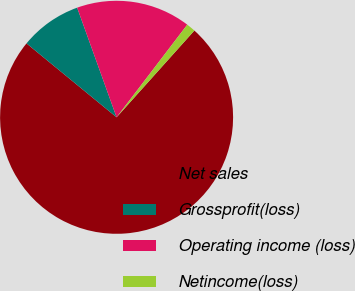<chart> <loc_0><loc_0><loc_500><loc_500><pie_chart><fcel>Net sales<fcel>Grossprofit(loss)<fcel>Operating income (loss)<fcel>Netincome(loss)<nl><fcel>74.3%<fcel>8.57%<fcel>15.87%<fcel>1.26%<nl></chart> 